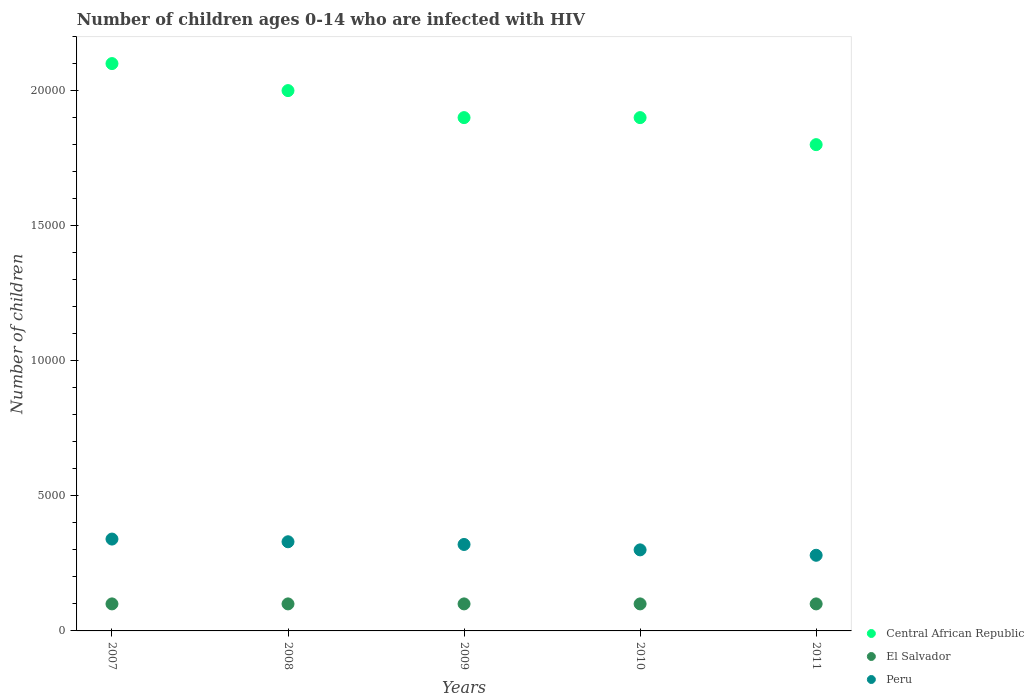How many different coloured dotlines are there?
Make the answer very short. 3. What is the number of HIV infected children in El Salvador in 2009?
Give a very brief answer. 1000. Across all years, what is the maximum number of HIV infected children in Peru?
Provide a succinct answer. 3400. Across all years, what is the minimum number of HIV infected children in El Salvador?
Ensure brevity in your answer.  1000. In which year was the number of HIV infected children in Central African Republic minimum?
Your answer should be compact. 2011. What is the total number of HIV infected children in Peru in the graph?
Give a very brief answer. 1.57e+04. What is the difference between the number of HIV infected children in Central African Republic in 2011 and the number of HIV infected children in El Salvador in 2007?
Provide a succinct answer. 1.70e+04. In the year 2008, what is the difference between the number of HIV infected children in El Salvador and number of HIV infected children in Peru?
Make the answer very short. -2300. In how many years, is the number of HIV infected children in Central African Republic greater than 17000?
Keep it short and to the point. 5. What is the ratio of the number of HIV infected children in Central African Republic in 2009 to that in 2011?
Ensure brevity in your answer.  1.06. Is the number of HIV infected children in Central African Republic in 2007 less than that in 2010?
Ensure brevity in your answer.  No. Is the difference between the number of HIV infected children in El Salvador in 2008 and 2009 greater than the difference between the number of HIV infected children in Peru in 2008 and 2009?
Provide a succinct answer. No. What is the difference between the highest and the second highest number of HIV infected children in Central African Republic?
Provide a short and direct response. 1000. What is the difference between the highest and the lowest number of HIV infected children in El Salvador?
Offer a terse response. 0. Is the sum of the number of HIV infected children in Peru in 2007 and 2011 greater than the maximum number of HIV infected children in Central African Republic across all years?
Your answer should be compact. No. Does the number of HIV infected children in Central African Republic monotonically increase over the years?
Your response must be concise. No. Is the number of HIV infected children in Central African Republic strictly greater than the number of HIV infected children in El Salvador over the years?
Make the answer very short. Yes. Is the number of HIV infected children in Peru strictly less than the number of HIV infected children in Central African Republic over the years?
Give a very brief answer. Yes. How many dotlines are there?
Your answer should be very brief. 3. How many years are there in the graph?
Your answer should be compact. 5. Are the values on the major ticks of Y-axis written in scientific E-notation?
Give a very brief answer. No. Does the graph contain any zero values?
Your answer should be very brief. No. Does the graph contain grids?
Give a very brief answer. No. Where does the legend appear in the graph?
Provide a short and direct response. Bottom right. What is the title of the graph?
Your response must be concise. Number of children ages 0-14 who are infected with HIV. Does "Papua New Guinea" appear as one of the legend labels in the graph?
Make the answer very short. No. What is the label or title of the Y-axis?
Offer a terse response. Number of children. What is the Number of children in Central African Republic in 2007?
Give a very brief answer. 2.10e+04. What is the Number of children of Peru in 2007?
Keep it short and to the point. 3400. What is the Number of children in El Salvador in 2008?
Ensure brevity in your answer.  1000. What is the Number of children of Peru in 2008?
Ensure brevity in your answer.  3300. What is the Number of children of Central African Republic in 2009?
Make the answer very short. 1.90e+04. What is the Number of children of El Salvador in 2009?
Ensure brevity in your answer.  1000. What is the Number of children in Peru in 2009?
Give a very brief answer. 3200. What is the Number of children in Central African Republic in 2010?
Provide a succinct answer. 1.90e+04. What is the Number of children in El Salvador in 2010?
Provide a succinct answer. 1000. What is the Number of children of Peru in 2010?
Ensure brevity in your answer.  3000. What is the Number of children of Central African Republic in 2011?
Your response must be concise. 1.80e+04. What is the Number of children in El Salvador in 2011?
Ensure brevity in your answer.  1000. What is the Number of children in Peru in 2011?
Provide a succinct answer. 2800. Across all years, what is the maximum Number of children of Central African Republic?
Provide a short and direct response. 2.10e+04. Across all years, what is the maximum Number of children of Peru?
Your answer should be compact. 3400. Across all years, what is the minimum Number of children of Central African Republic?
Your answer should be compact. 1.80e+04. Across all years, what is the minimum Number of children in Peru?
Provide a succinct answer. 2800. What is the total Number of children of Central African Republic in the graph?
Your answer should be very brief. 9.70e+04. What is the total Number of children of Peru in the graph?
Your answer should be very brief. 1.57e+04. What is the difference between the Number of children in El Salvador in 2007 and that in 2008?
Make the answer very short. 0. What is the difference between the Number of children of El Salvador in 2007 and that in 2009?
Offer a terse response. 0. What is the difference between the Number of children in Central African Republic in 2007 and that in 2010?
Give a very brief answer. 2000. What is the difference between the Number of children of Central African Republic in 2007 and that in 2011?
Ensure brevity in your answer.  3000. What is the difference between the Number of children of Peru in 2007 and that in 2011?
Provide a succinct answer. 600. What is the difference between the Number of children of Peru in 2008 and that in 2009?
Offer a very short reply. 100. What is the difference between the Number of children in Central African Republic in 2008 and that in 2010?
Your answer should be very brief. 1000. What is the difference between the Number of children in Peru in 2008 and that in 2010?
Make the answer very short. 300. What is the difference between the Number of children of Central African Republic in 2008 and that in 2011?
Your response must be concise. 2000. What is the difference between the Number of children in Central African Republic in 2009 and that in 2010?
Give a very brief answer. 0. What is the difference between the Number of children of El Salvador in 2009 and that in 2010?
Offer a very short reply. 0. What is the difference between the Number of children in El Salvador in 2009 and that in 2011?
Ensure brevity in your answer.  0. What is the difference between the Number of children in Central African Republic in 2007 and the Number of children in Peru in 2008?
Ensure brevity in your answer.  1.77e+04. What is the difference between the Number of children in El Salvador in 2007 and the Number of children in Peru in 2008?
Your answer should be very brief. -2300. What is the difference between the Number of children of Central African Republic in 2007 and the Number of children of Peru in 2009?
Your response must be concise. 1.78e+04. What is the difference between the Number of children of El Salvador in 2007 and the Number of children of Peru in 2009?
Offer a very short reply. -2200. What is the difference between the Number of children of Central African Republic in 2007 and the Number of children of El Salvador in 2010?
Make the answer very short. 2.00e+04. What is the difference between the Number of children in Central African Republic in 2007 and the Number of children in Peru in 2010?
Your answer should be compact. 1.80e+04. What is the difference between the Number of children in El Salvador in 2007 and the Number of children in Peru in 2010?
Make the answer very short. -2000. What is the difference between the Number of children of Central African Republic in 2007 and the Number of children of El Salvador in 2011?
Provide a short and direct response. 2.00e+04. What is the difference between the Number of children of Central African Republic in 2007 and the Number of children of Peru in 2011?
Your answer should be compact. 1.82e+04. What is the difference between the Number of children of El Salvador in 2007 and the Number of children of Peru in 2011?
Give a very brief answer. -1800. What is the difference between the Number of children of Central African Republic in 2008 and the Number of children of El Salvador in 2009?
Your answer should be compact. 1.90e+04. What is the difference between the Number of children in Central African Republic in 2008 and the Number of children in Peru in 2009?
Make the answer very short. 1.68e+04. What is the difference between the Number of children of El Salvador in 2008 and the Number of children of Peru in 2009?
Your response must be concise. -2200. What is the difference between the Number of children of Central African Republic in 2008 and the Number of children of El Salvador in 2010?
Keep it short and to the point. 1.90e+04. What is the difference between the Number of children of Central African Republic in 2008 and the Number of children of Peru in 2010?
Your answer should be very brief. 1.70e+04. What is the difference between the Number of children in El Salvador in 2008 and the Number of children in Peru in 2010?
Your response must be concise. -2000. What is the difference between the Number of children of Central African Republic in 2008 and the Number of children of El Salvador in 2011?
Your response must be concise. 1.90e+04. What is the difference between the Number of children in Central African Republic in 2008 and the Number of children in Peru in 2011?
Provide a short and direct response. 1.72e+04. What is the difference between the Number of children of El Salvador in 2008 and the Number of children of Peru in 2011?
Give a very brief answer. -1800. What is the difference between the Number of children of Central African Republic in 2009 and the Number of children of El Salvador in 2010?
Provide a short and direct response. 1.80e+04. What is the difference between the Number of children of Central African Republic in 2009 and the Number of children of Peru in 2010?
Keep it short and to the point. 1.60e+04. What is the difference between the Number of children in El Salvador in 2009 and the Number of children in Peru in 2010?
Give a very brief answer. -2000. What is the difference between the Number of children of Central African Republic in 2009 and the Number of children of El Salvador in 2011?
Your answer should be compact. 1.80e+04. What is the difference between the Number of children of Central African Republic in 2009 and the Number of children of Peru in 2011?
Ensure brevity in your answer.  1.62e+04. What is the difference between the Number of children in El Salvador in 2009 and the Number of children in Peru in 2011?
Your response must be concise. -1800. What is the difference between the Number of children of Central African Republic in 2010 and the Number of children of El Salvador in 2011?
Keep it short and to the point. 1.80e+04. What is the difference between the Number of children of Central African Republic in 2010 and the Number of children of Peru in 2011?
Your answer should be compact. 1.62e+04. What is the difference between the Number of children in El Salvador in 2010 and the Number of children in Peru in 2011?
Offer a terse response. -1800. What is the average Number of children of Central African Republic per year?
Provide a short and direct response. 1.94e+04. What is the average Number of children in Peru per year?
Provide a succinct answer. 3140. In the year 2007, what is the difference between the Number of children in Central African Republic and Number of children in Peru?
Provide a succinct answer. 1.76e+04. In the year 2007, what is the difference between the Number of children of El Salvador and Number of children of Peru?
Provide a succinct answer. -2400. In the year 2008, what is the difference between the Number of children of Central African Republic and Number of children of El Salvador?
Your answer should be compact. 1.90e+04. In the year 2008, what is the difference between the Number of children in Central African Republic and Number of children in Peru?
Ensure brevity in your answer.  1.67e+04. In the year 2008, what is the difference between the Number of children of El Salvador and Number of children of Peru?
Offer a very short reply. -2300. In the year 2009, what is the difference between the Number of children in Central African Republic and Number of children in El Salvador?
Make the answer very short. 1.80e+04. In the year 2009, what is the difference between the Number of children of Central African Republic and Number of children of Peru?
Your response must be concise. 1.58e+04. In the year 2009, what is the difference between the Number of children in El Salvador and Number of children in Peru?
Keep it short and to the point. -2200. In the year 2010, what is the difference between the Number of children in Central African Republic and Number of children in El Salvador?
Offer a very short reply. 1.80e+04. In the year 2010, what is the difference between the Number of children in Central African Republic and Number of children in Peru?
Your answer should be very brief. 1.60e+04. In the year 2010, what is the difference between the Number of children of El Salvador and Number of children of Peru?
Offer a very short reply. -2000. In the year 2011, what is the difference between the Number of children in Central African Republic and Number of children in El Salvador?
Make the answer very short. 1.70e+04. In the year 2011, what is the difference between the Number of children of Central African Republic and Number of children of Peru?
Give a very brief answer. 1.52e+04. In the year 2011, what is the difference between the Number of children in El Salvador and Number of children in Peru?
Give a very brief answer. -1800. What is the ratio of the Number of children of El Salvador in 2007 to that in 2008?
Make the answer very short. 1. What is the ratio of the Number of children in Peru in 2007 to that in 2008?
Your response must be concise. 1.03. What is the ratio of the Number of children in Central African Republic in 2007 to that in 2009?
Ensure brevity in your answer.  1.11. What is the ratio of the Number of children of Peru in 2007 to that in 2009?
Make the answer very short. 1.06. What is the ratio of the Number of children of Central African Republic in 2007 to that in 2010?
Make the answer very short. 1.11. What is the ratio of the Number of children of El Salvador in 2007 to that in 2010?
Offer a very short reply. 1. What is the ratio of the Number of children of Peru in 2007 to that in 2010?
Offer a very short reply. 1.13. What is the ratio of the Number of children in Central African Republic in 2007 to that in 2011?
Provide a succinct answer. 1.17. What is the ratio of the Number of children in Peru in 2007 to that in 2011?
Keep it short and to the point. 1.21. What is the ratio of the Number of children in Central African Republic in 2008 to that in 2009?
Provide a succinct answer. 1.05. What is the ratio of the Number of children in El Salvador in 2008 to that in 2009?
Provide a succinct answer. 1. What is the ratio of the Number of children in Peru in 2008 to that in 2009?
Give a very brief answer. 1.03. What is the ratio of the Number of children in Central African Republic in 2008 to that in 2010?
Keep it short and to the point. 1.05. What is the ratio of the Number of children of Peru in 2008 to that in 2010?
Give a very brief answer. 1.1. What is the ratio of the Number of children of Peru in 2008 to that in 2011?
Offer a very short reply. 1.18. What is the ratio of the Number of children in Central African Republic in 2009 to that in 2010?
Offer a terse response. 1. What is the ratio of the Number of children in Peru in 2009 to that in 2010?
Your answer should be very brief. 1.07. What is the ratio of the Number of children of Central African Republic in 2009 to that in 2011?
Your response must be concise. 1.06. What is the ratio of the Number of children of El Salvador in 2009 to that in 2011?
Offer a very short reply. 1. What is the ratio of the Number of children of Central African Republic in 2010 to that in 2011?
Provide a succinct answer. 1.06. What is the ratio of the Number of children in Peru in 2010 to that in 2011?
Keep it short and to the point. 1.07. What is the difference between the highest and the second highest Number of children in Central African Republic?
Ensure brevity in your answer.  1000. What is the difference between the highest and the lowest Number of children of Central African Republic?
Make the answer very short. 3000. What is the difference between the highest and the lowest Number of children of El Salvador?
Keep it short and to the point. 0. What is the difference between the highest and the lowest Number of children of Peru?
Make the answer very short. 600. 